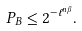Convert formula to latex. <formula><loc_0><loc_0><loc_500><loc_500>P _ { B } \leq 2 ^ { - \ell ^ { n \beta } } .</formula> 